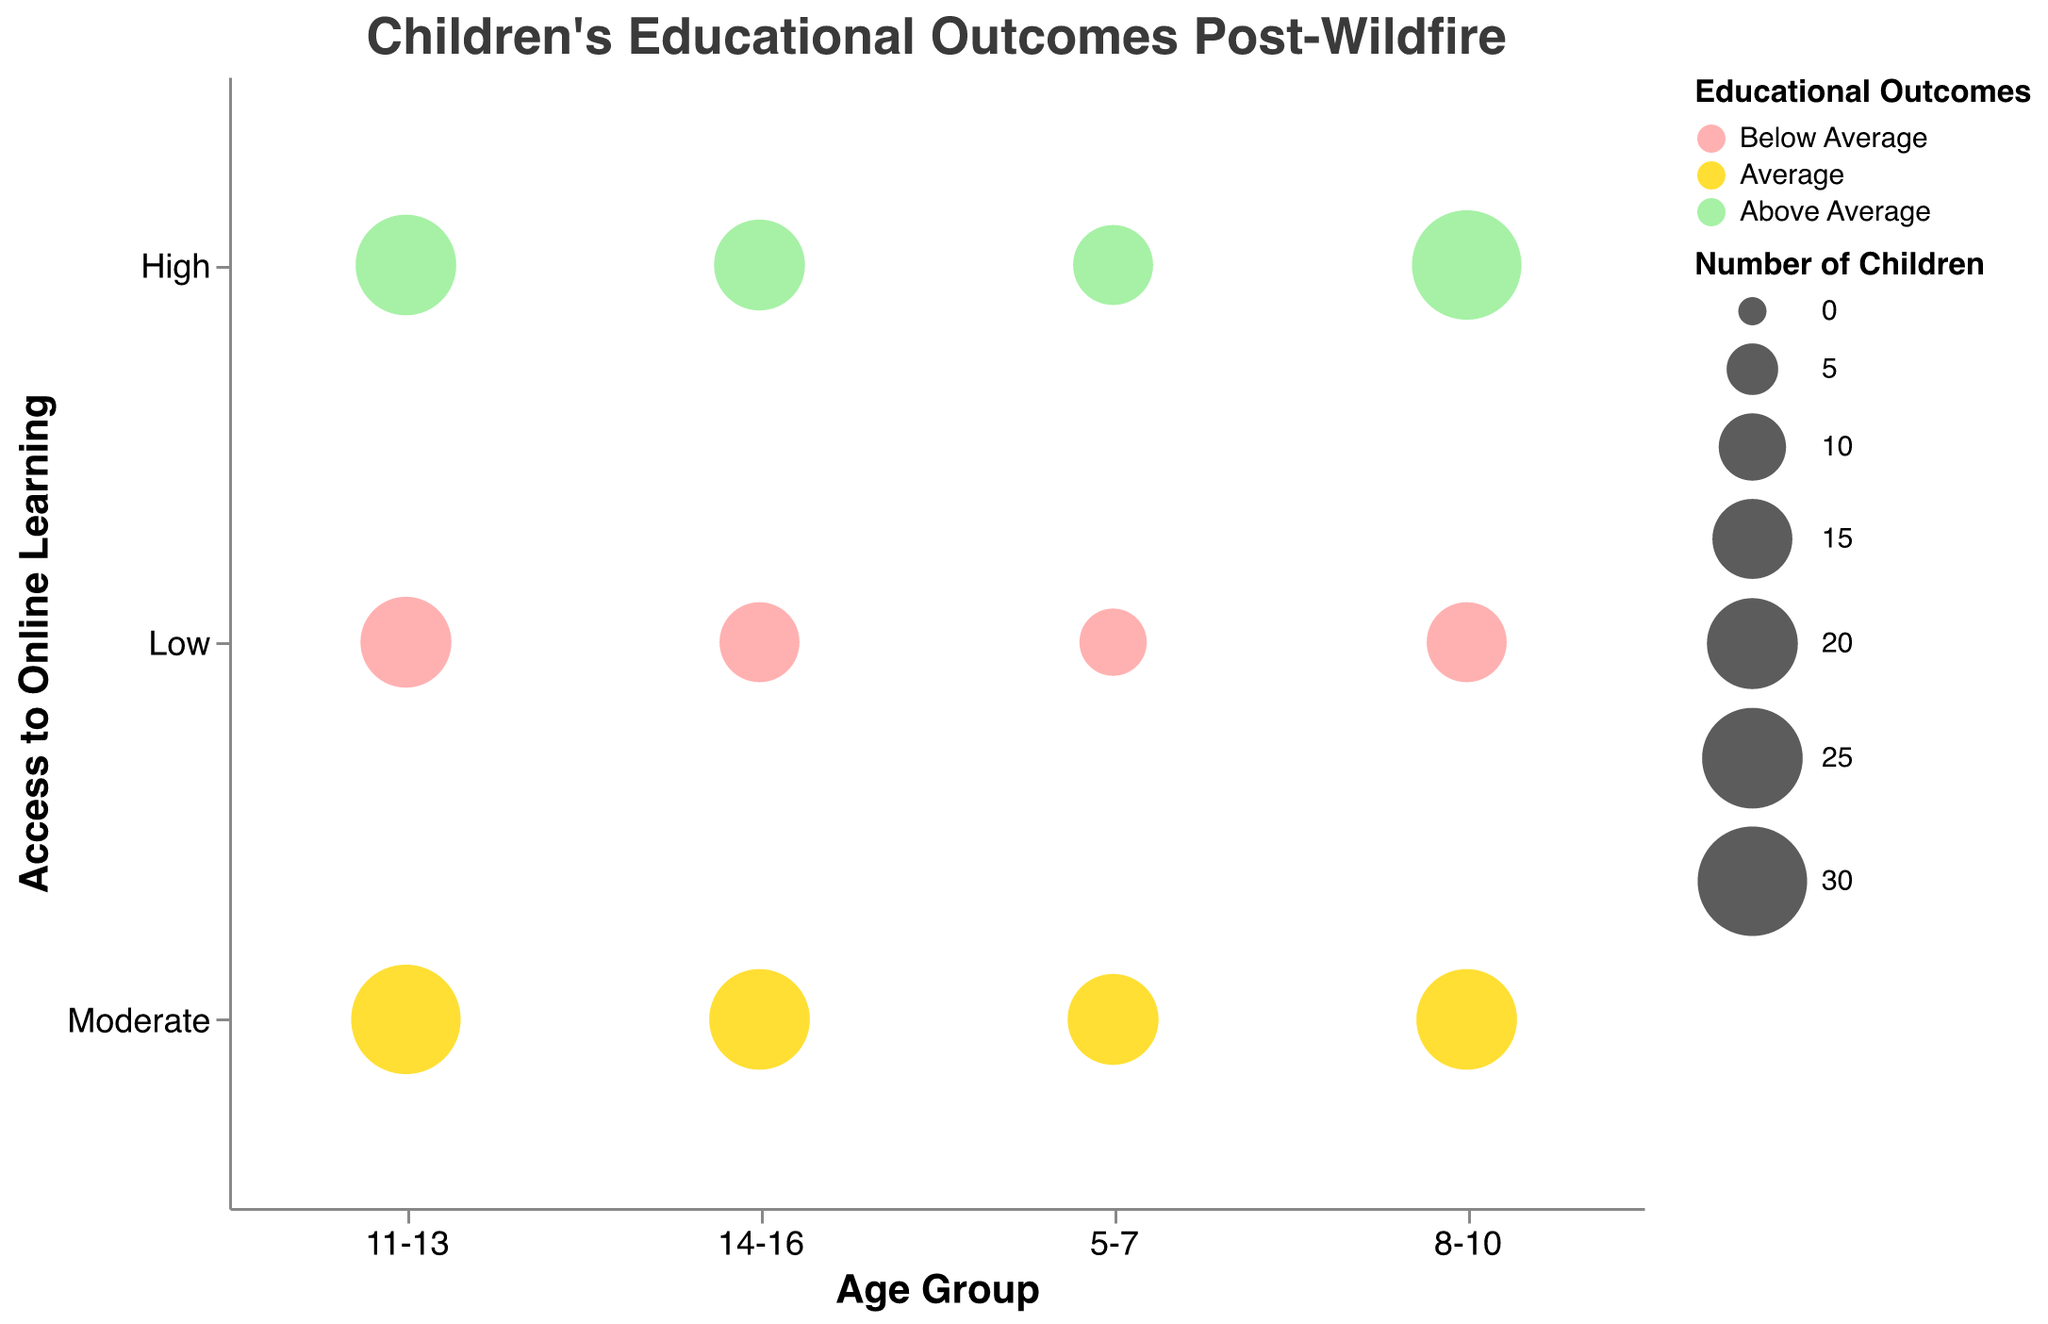What is the title of the figure? The title is usually located at the top of the chart in a larger font and gives a summary of what the chart represents. Here, the title is presented in Helvetica font with a size of 18 and color #3a3a3a.
Answer: Children's Educational Outcomes Post-Wildfire Which age group has the smallest bubble representing the lowest number of children? The size of the bubble corresponds to the number of children. The smallest bubble will have the lowest number of children mentioned next to it.
Answer: 5-7 years, Low access with 10 children What is the color associated with 'Above Average' educational outcomes? Colors in the chart are used to represent different educational outcomes. The color corresponding to 'Above Average' outcomes is identified in the chart legend.
Answer: Light Green (#90EE90) How many children aged 11-13 have 'Average' educational outcomes with 'Moderate' access to online learning tools? To find this, locate the data point where Age is 11-13, Access to Online Learning is Moderate and Educational Outcomes are Average. Then look at the size of the bubble to determine the number of children.
Answer: 30 Which age group has the highest number of children with 'High' access to online learning tools and 'Above Average' educational outcomes? Compare the size of bubbles across different age groups with 'High' access to online learning and 'Above Average' educational outcomes.
Answer: 8-10 years with 30 children Compare the number of children aged 5-7 with 'Low' access to online learning tools to those aged 11-13 with 'Low' access. Which group has more children? Locate the bubbles for both the 5-7 and 11-13 age groups with 'Low' access and compare their sizes to determine which has more children.
Answer: Age group 11-13 (20 children) What is the educational outcome for majority of 8-10 year-olds with 'Moderate' access to online learning tools? Look at the bubble for 8-10 age group with 'Moderate' access and check the color to determine their educational outcomes.
Answer: Average (Yellow) Is there a significant difference in educational outcomes between the children aged 14-16 with High access and Low access to online learning tools? Compare the colors and sizes of the bubbles for 14-16 age group with 'High' and 'Low' access.
Answer: High access: Above Average (green, 20 children), Low access: Below Average (red, 15 children) Which age group has the most children with 'Below Average' educational outcomes? Find the largest bubble with 'Below Average' outcomes and check the corresponding age group.
Answer: 11-13 years with 20 children 